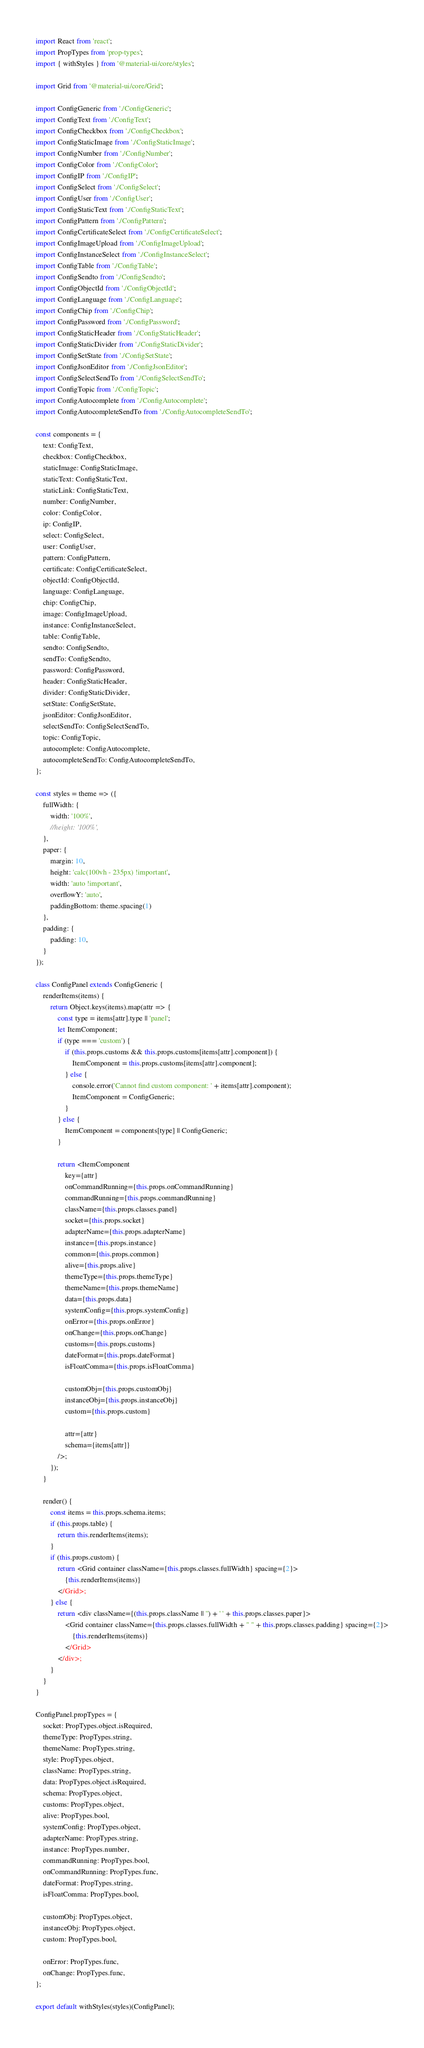<code> <loc_0><loc_0><loc_500><loc_500><_JavaScript_>import React from 'react';
import PropTypes from 'prop-types';
import { withStyles } from '@material-ui/core/styles';

import Grid from '@material-ui/core/Grid';

import ConfigGeneric from './ConfigGeneric';
import ConfigText from './ConfigText';
import ConfigCheckbox from './ConfigCheckbox';
import ConfigStaticImage from './ConfigStaticImage';
import ConfigNumber from './ConfigNumber';
import ConfigColor from './ConfigColor';
import ConfigIP from './ConfigIP';
import ConfigSelect from './ConfigSelect';
import ConfigUser from './ConfigUser';
import ConfigStaticText from './ConfigStaticText';
import ConfigPattern from './ConfigPattern';
import ConfigCertificateSelect from './ConfigCertificateSelect';
import ConfigImageUpload from './ConfigImageUpload';
import ConfigInstanceSelect from './ConfigInstanceSelect';
import ConfigTable from './ConfigTable';
import ConfigSendto from './ConfigSendto';
import ConfigObjectId from './ConfigObjectId';
import ConfigLanguage from './ConfigLanguage';
import ConfigChip from './ConfigChip';
import ConfigPassword from './ConfigPassword';
import ConfigStaticHeader from './ConfigStaticHeader';
import ConfigStaticDivider from './ConfigStaticDivider';
import ConfigSetState from './ConfigSetState';
import ConfigJsonEditor from './ConfigJsonEditor';
import ConfigSelectSendTo from './ConfigSelectSendTo';
import ConfigTopic from './ConfigTopic';
import ConfigAutocomplete from './ConfigAutocomplete';
import ConfigAutocompleteSendTo from './ConfigAutocompleteSendTo';

const components = {
    text: ConfigText,
    checkbox: ConfigCheckbox,
    staticImage: ConfigStaticImage,
    staticText: ConfigStaticText,
    staticLink: ConfigStaticText,
    number: ConfigNumber,
    color: ConfigColor,
    ip: ConfigIP,
    select: ConfigSelect,
    user: ConfigUser,
    pattern: ConfigPattern,
    certificate: ConfigCertificateSelect,
    objectId: ConfigObjectId,
    language: ConfigLanguage,
    chip: ConfigChip,
    image: ConfigImageUpload,
    instance: ConfigInstanceSelect,
    table: ConfigTable,
    sendto: ConfigSendto,
    sendTo: ConfigSendto,
    password: ConfigPassword,
    header: ConfigStaticHeader,
    divider: ConfigStaticDivider,
    setState: ConfigSetState,
    jsonEditor: ConfigJsonEditor,
    selectSendTo: ConfigSelectSendTo,
    topic: ConfigTopic,
    autocomplete: ConfigAutocomplete,
    autocompleteSendTo: ConfigAutocompleteSendTo,
};

const styles = theme => ({
    fullWidth: {
        width: '100%',
        //height: '100%',
    },
    paper: {
        margin: 10,
        height: 'calc(100vh - 235px) !important',
        width: 'auto !important',
        overflowY: 'auto',
        paddingBottom: theme.spacing(1)
    },
    padding: {
        padding: 10,
    }
});

class ConfigPanel extends ConfigGeneric {
    renderItems(items) {
        return Object.keys(items).map(attr => {
            const type = items[attr].type || 'panel';
            let ItemComponent;
            if (type === 'custom') {
                if (this.props.customs && this.props.customs[items[attr].component]) {
                    ItemComponent = this.props.customs[items[attr].component];
                } else {
                    console.error('Cannot find custom component: ' + items[attr].component);
                    ItemComponent = ConfigGeneric;
                }
            } else {
                ItemComponent = components[type] || ConfigGeneric;
            }

            return <ItemComponent
                key={attr}
                onCommandRunning={this.props.onCommandRunning}
                commandRunning={this.props.commandRunning}
                className={this.props.classes.panel}
                socket={this.props.socket}
                adapterName={this.props.adapterName}
                instance={this.props.instance}
                common={this.props.common}
                alive={this.props.alive}
                themeType={this.props.themeType}
                themeName={this.props.themeName}
                data={this.props.data}
                systemConfig={this.props.systemConfig}
                onError={this.props.onError}
                onChange={this.props.onChange}
                customs={this.props.customs}
                dateFormat={this.props.dateFormat}
                isFloatComma={this.props.isFloatComma}

                customObj={this.props.customObj}
                instanceObj={this.props.instanceObj}
                custom={this.props.custom}

                attr={attr}
                schema={items[attr]}
            />;
        });
    }

    render() {
        const items = this.props.schema.items;
        if (this.props.table) {
            return this.renderItems(items);
        }
        if (this.props.custom) {
            return <Grid container className={this.props.classes.fullWidth} spacing={2}>
                {this.renderItems(items)}
            </Grid>;
        } else {
            return <div className={(this.props.className || '') + ' ' + this.props.classes.paper}>
                <Grid container className={this.props.classes.fullWidth + " " + this.props.classes.padding} spacing={2}>
                    {this.renderItems(items)}
                </Grid>
            </div>;
        }
    }
}

ConfigPanel.propTypes = {
    socket: PropTypes.object.isRequired,
    themeType: PropTypes.string,
    themeName: PropTypes.string,
    style: PropTypes.object,
    className: PropTypes.string,
    data: PropTypes.object.isRequired,
    schema: PropTypes.object,
    customs: PropTypes.object,
    alive: PropTypes.bool,
    systemConfig: PropTypes.object,
    adapterName: PropTypes.string,
    instance: PropTypes.number,
    commandRunning: PropTypes.bool,
    onCommandRunning: PropTypes.func,
    dateFormat: PropTypes.string,
    isFloatComma: PropTypes.bool,

    customObj: PropTypes.object,
    instanceObj: PropTypes.object,
    custom: PropTypes.bool,

    onError: PropTypes.func,
    onChange: PropTypes.func,
};

export default withStyles(styles)(ConfigPanel);</code> 